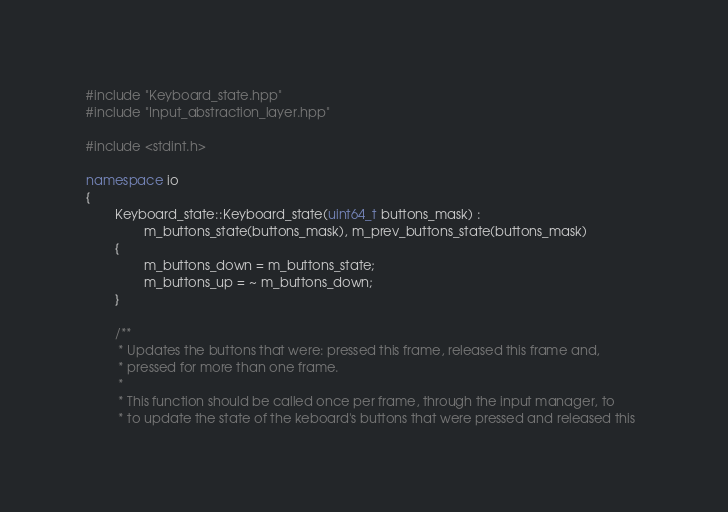<code> <loc_0><loc_0><loc_500><loc_500><_C++_>#include "Keyboard_state.hpp"
#include "Input_abstraction_layer.hpp"

#include <stdint.h>

namespace io
{
        Keyboard_state::Keyboard_state(uint64_t buttons_mask) : 
                m_buttons_state(buttons_mask), m_prev_buttons_state(buttons_mask)
        {
                m_buttons_down = m_buttons_state;
                m_buttons_up = ~ m_buttons_down;
        }

        /**
         * Updates the buttons that were: pressed this frame, released this frame and,
         * pressed for more than one frame.
         *
         * This function should be called once per frame, through the input manager, to  
         * to update the state of the keboard's buttons that were pressed and released this  </code> 